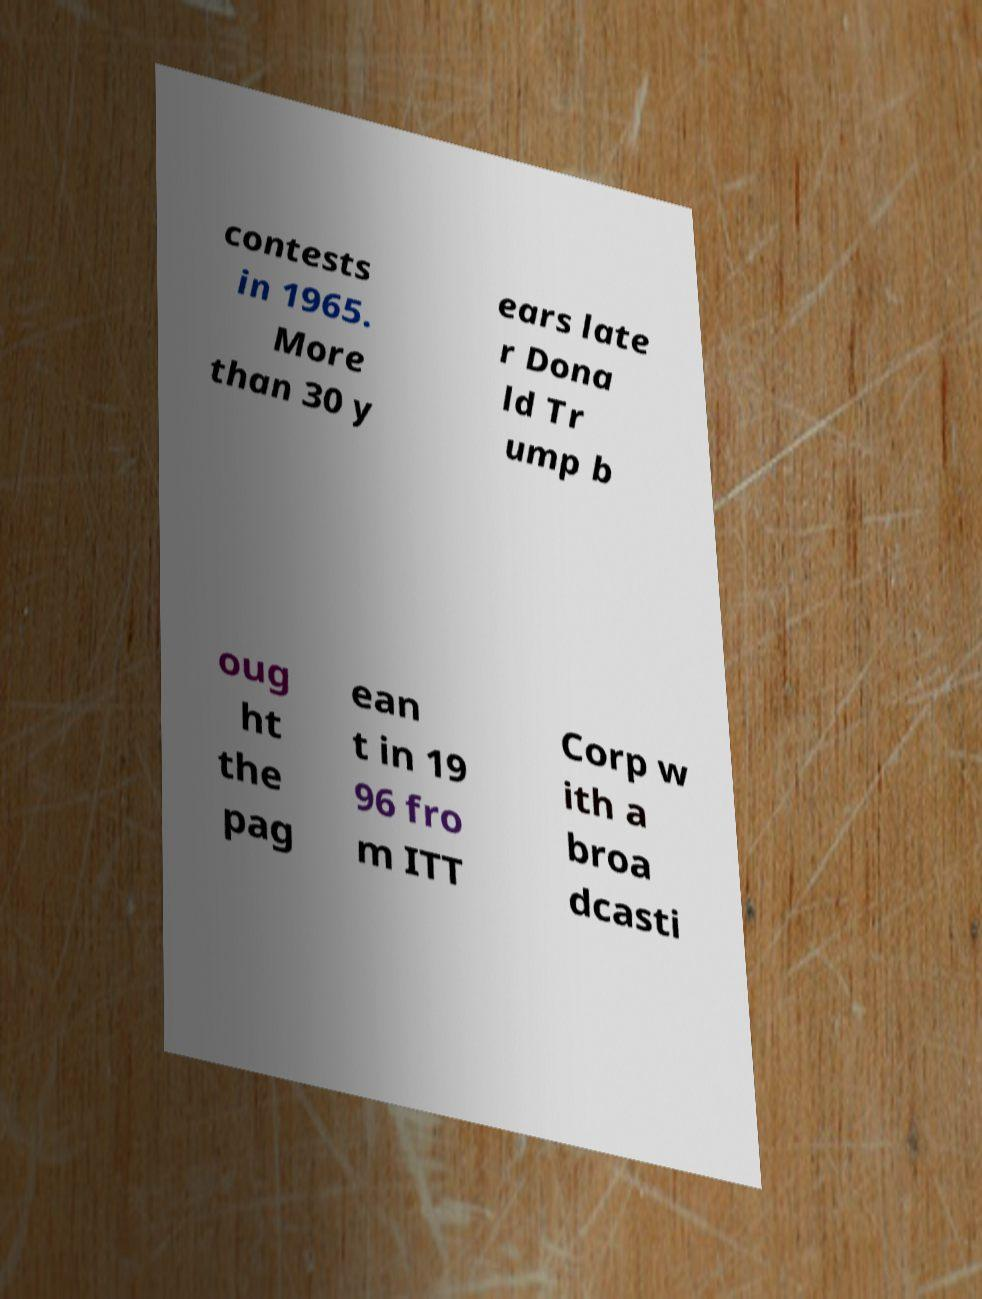What messages or text are displayed in this image? I need them in a readable, typed format. contests in 1965. More than 30 y ears late r Dona ld Tr ump b oug ht the pag ean t in 19 96 fro m ITT Corp w ith a broa dcasti 